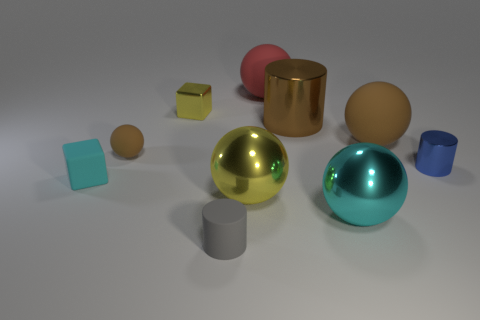There is a yellow metal thing in front of the small block in front of the large brown thing in front of the big cylinder; what is its size?
Your response must be concise. Large. What number of red objects are the same material as the tiny cyan thing?
Provide a short and direct response. 1. There is a metal cylinder that is behind the brown ball on the right side of the large red rubber ball; what color is it?
Provide a succinct answer. Brown. How many things are either small cyan blocks or brown rubber balls on the left side of the small yellow cube?
Offer a terse response. 2. Is there another rubber sphere that has the same color as the small rubber ball?
Provide a short and direct response. Yes. How many yellow things are small blocks or small matte blocks?
Make the answer very short. 1. What number of other things are there of the same size as the cyan metal sphere?
Make the answer very short. 4. What number of large objects are matte cubes or red shiny balls?
Your answer should be very brief. 0. There is a matte cube; is its size the same as the brown rubber ball on the left side of the small yellow metallic block?
Your response must be concise. Yes. How many other objects are there of the same shape as the tiny gray object?
Provide a short and direct response. 2. 